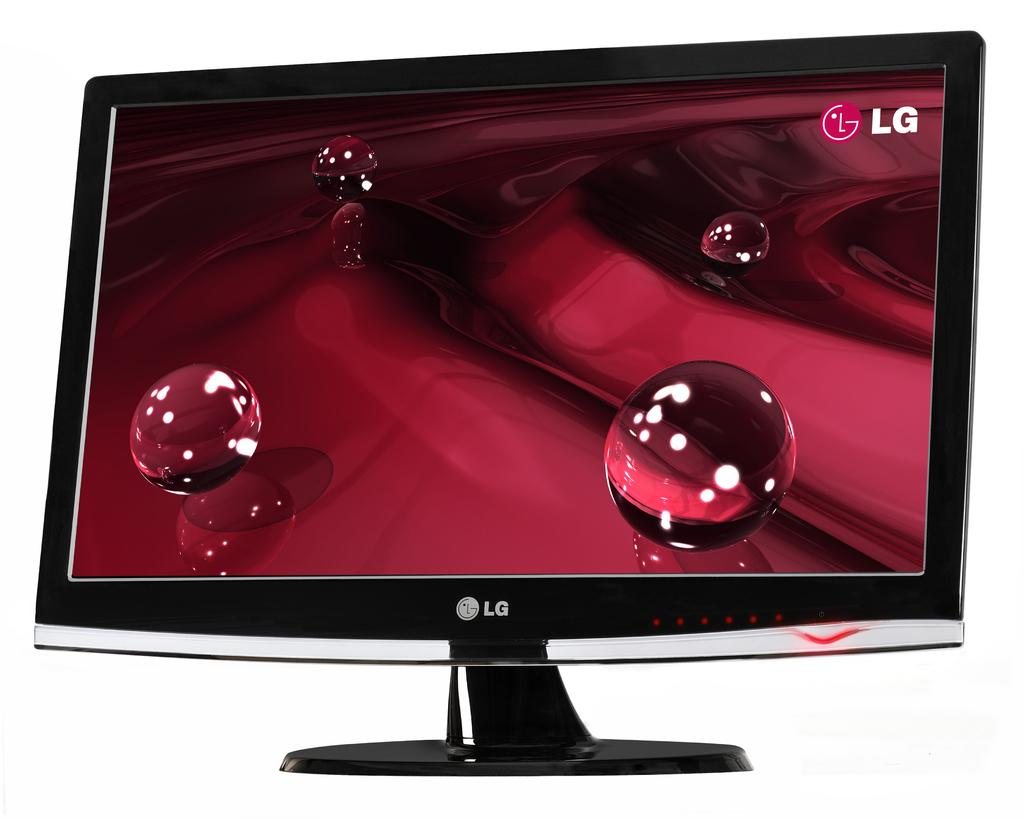<image>
Summarize the visual content of the image. An LG television with a pink screen with bubbles. 